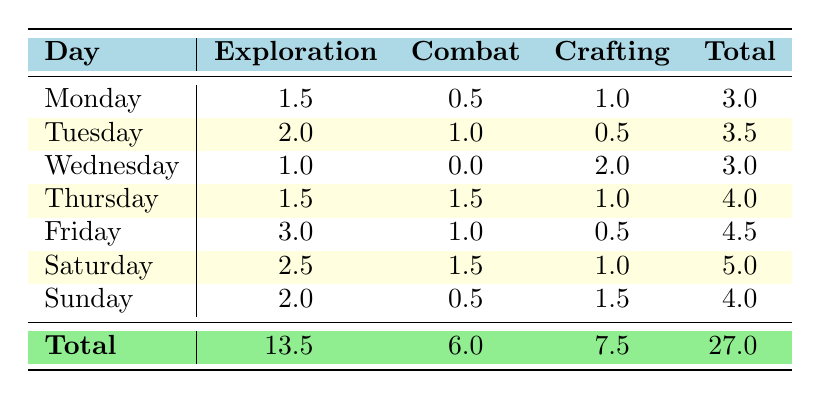What day had the highest time spent on Exploration? Looking at the Exploration column, each day's time is checked: Monday (1.5), Tuesday (2.0), Wednesday (1.0), Thursday (1.5), Friday (3.0), Saturday (2.5), and Sunday (2.0). The highest value is on Friday with 3.0 hours.
Answer: Friday What was the total time spent on Crafting throughout the week? To calculate the total Crafting time, the Crafting values for each day are summed: 1.0 (Monday) + 0.5 (Tuesday) + 2.0 (Wednesday) + 1.0 (Thursday) + 0.5 (Friday) + 1.0 (Saturday) + 1.5 (Sunday) = 7.5.
Answer: 7.5 Did Saturday have more time spent on Combat than Tuesday? Comparing the Combat values: Saturday is 1.5 hours, and Tuesday is 1.0 hours. Since 1.5 > 1.0, it means Saturday indeed had more time spent on Combat than Tuesday.
Answer: Yes What is the difference in total time spent on Exploration between Friday and Monday? First, find the total Exploration time for Friday (3.0) and Monday (1.5). Then, calculate the difference: 3.0 - 1.5 = 1.5.
Answer: 1.5 What day had the least total time spent on activities? Summing the total for each day: Monday (3.0), Tuesday (3.5), Wednesday (3.0), Thursday (4.0), Friday (4.5), Saturday (5.0), Sunday (4.0). The minimum total is 3.0, which appears on both Monday and Wednesday.
Answer: Monday and Wednesday What was the average time spent on Combat for the week? The total Combat time is 6.0 hours. Since there are 7 days, the average is calculated as 6.0 / 7 = approximately 0.857.
Answer: 0.857 Which day had the highest total time spent on all activities? The total time for each day is: Monday (3.0), Tuesday (3.5), Wednesday (3.0), Thursday (4.0), Friday (4.5), Saturday (5.0), Sunday (4.0). The highest total time is on Saturday with 5.0 hours.
Answer: Saturday Is the total time spent on Combat more than the total time spent on Crafting throughout the week? The total Combat is 6.0 hours, while the total Crafting is 7.5 hours. Since 6.0 is less than 7.5, the statement is false.
Answer: No 